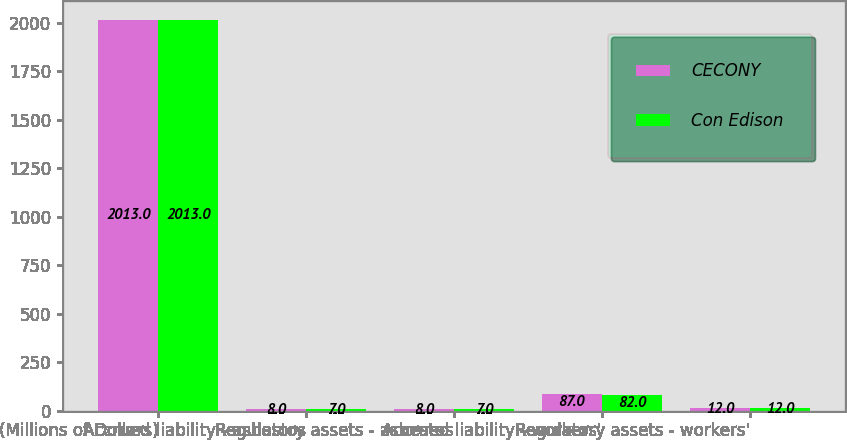<chart> <loc_0><loc_0><loc_500><loc_500><stacked_bar_chart><ecel><fcel>(Millions of Dollars)<fcel>Accrued liability - asbestos<fcel>Regulatory assets - asbestos<fcel>Accrued liability - workers'<fcel>Regulatory assets - workers'<nl><fcel>CECONY<fcel>2013<fcel>8<fcel>8<fcel>87<fcel>12<nl><fcel>Con Edison<fcel>2013<fcel>7<fcel>7<fcel>82<fcel>12<nl></chart> 